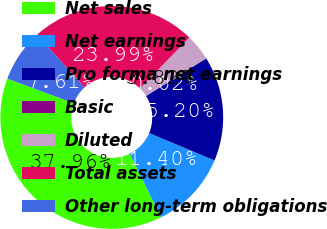Convert chart to OTSL. <chart><loc_0><loc_0><loc_500><loc_500><pie_chart><fcel>Net sales<fcel>Net earnings<fcel>Pro forma net earnings<fcel>Basic<fcel>Diluted<fcel>Total assets<fcel>Other long-term obligations<nl><fcel>37.96%<fcel>11.4%<fcel>15.2%<fcel>0.02%<fcel>3.82%<fcel>23.99%<fcel>7.61%<nl></chart> 